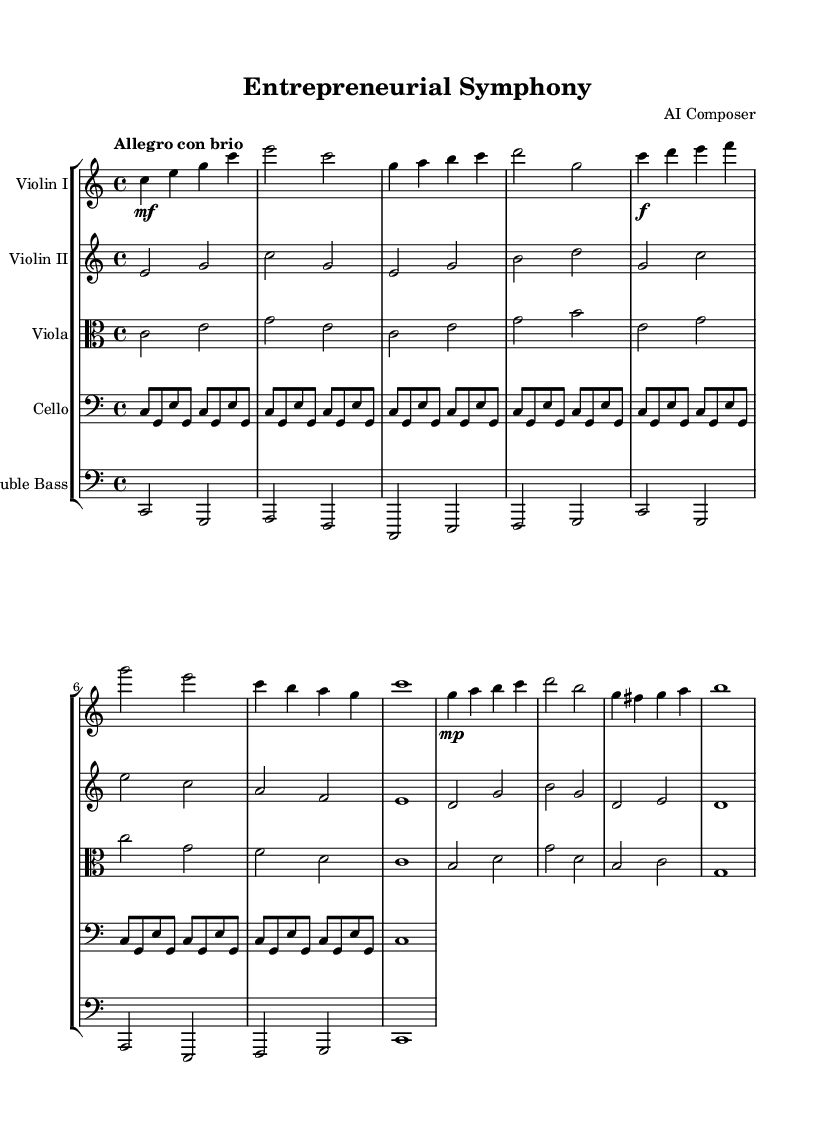what is the key signature of this music? The key signature is C major, which has no sharps or flats.
Answer: C major what is the time signature of the piece? The time signature is indicated as 4/4, which means there are four beats in each measure and the quarter note gets one beat.
Answer: 4/4 what is the tempo marking for this symphony? The tempo marking is "Allegro con brio," which suggests a lively and brisk pace.
Answer: Allegro con brio how many themes are presented in the orchestral composition? Two distinct themes (Theme A and Theme B) are presented in the composition. The first theme is introduced early and the second theme follows later.
Answer: 2 which instrument has the main ostinato? The cello has the main ostinato, which provides a repeating melodic figure throughout the piece.
Answer: Cello what is the role of the bass in this composition? The bass provides a chord progression that supports the harmony and foundation of the orchestral texture, enhancing the overall depth of the music.
Answer: Harmonic foundation which instrument plays the simplified part in this score? Both the second violin and viola sections play simplified parts, which accompany the main themes and provide additional voice support.
Answer: Violin II and Viola 